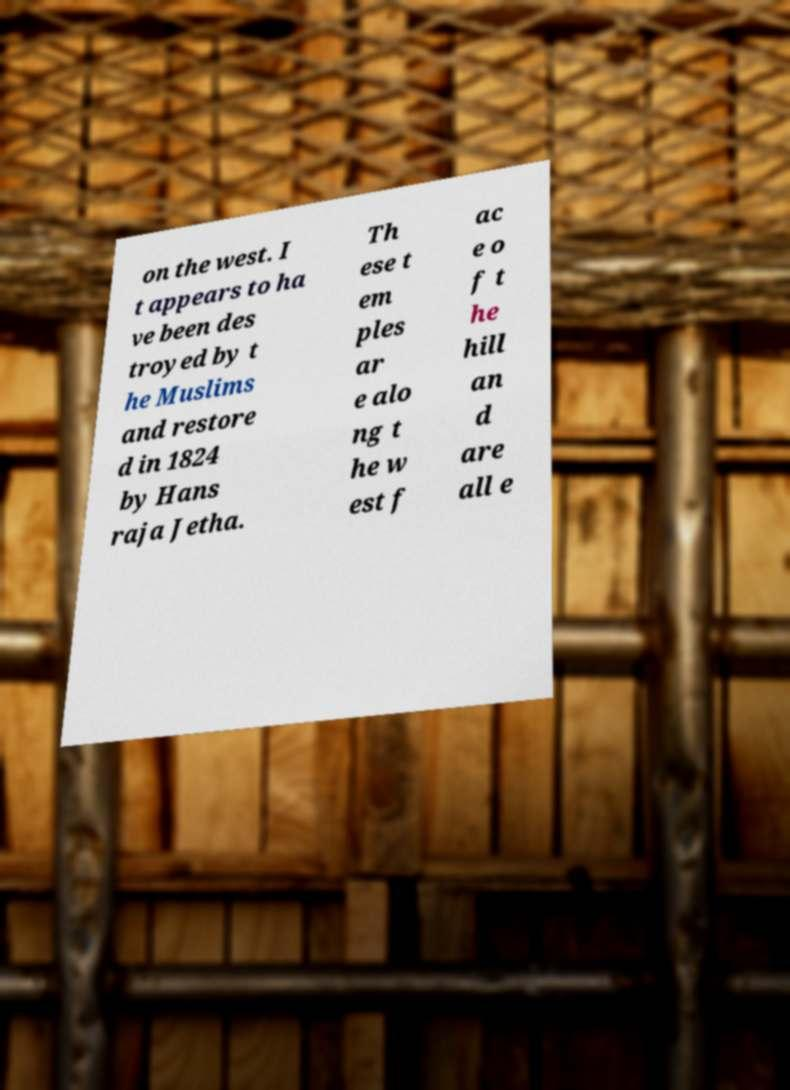Please read and relay the text visible in this image. What does it say? on the west. I t appears to ha ve been des troyed by t he Muslims and restore d in 1824 by Hans raja Jetha. Th ese t em ples ar e alo ng t he w est f ac e o f t he hill an d are all e 